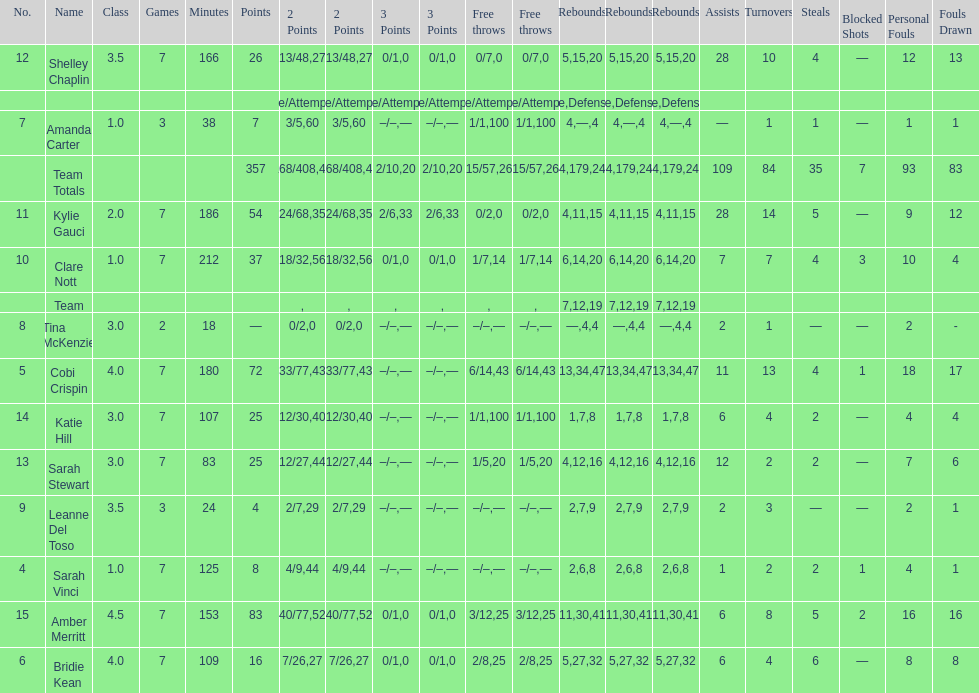Which player had the most total points? Amber Merritt. 